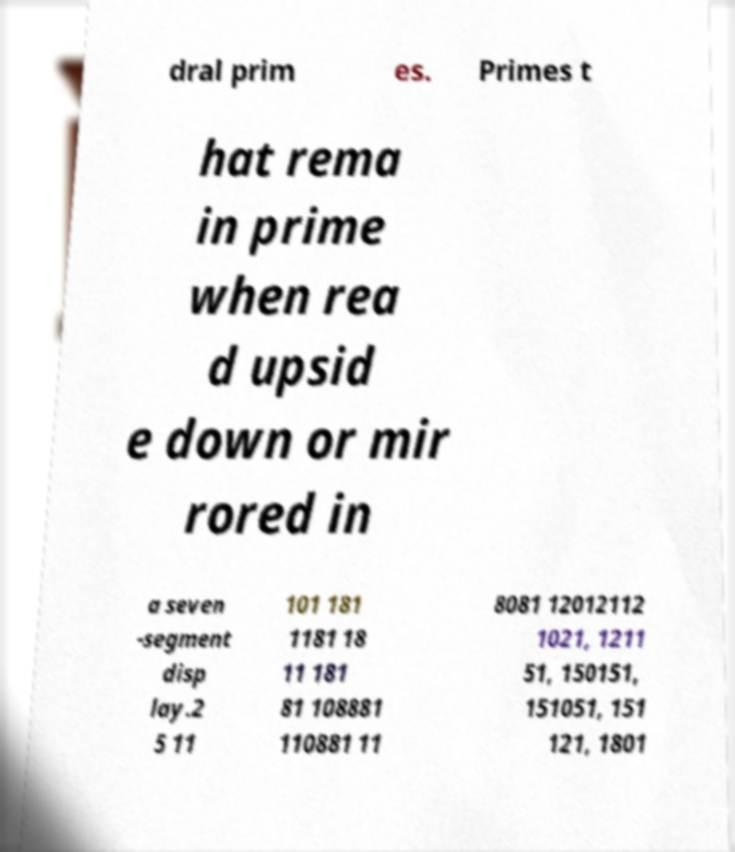Could you extract and type out the text from this image? dral prim es. Primes t hat rema in prime when rea d upsid e down or mir rored in a seven -segment disp lay.2 5 11 101 181 1181 18 11 181 81 108881 110881 11 8081 12012112 1021, 1211 51, 150151, 151051, 151 121, 1801 